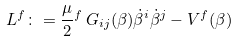Convert formula to latex. <formula><loc_0><loc_0><loc_500><loc_500>L ^ { f } \colon = \frac { \mu } { 2 } { ^ { f } } \, G _ { i j } ( \beta ) \dot { \beta } ^ { i } \dot { \beta } ^ { j } - V ^ { f } ( \beta )</formula> 